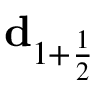<formula> <loc_0><loc_0><loc_500><loc_500>d _ { 1 + \frac { 1 } { 2 } }</formula> 